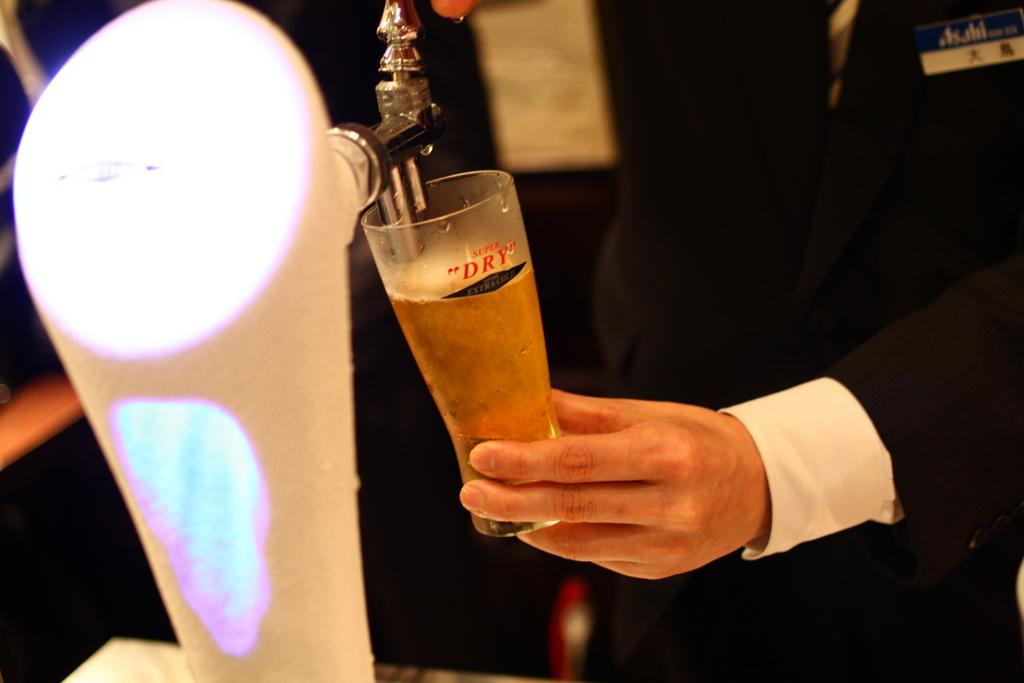<image>
Offer a succinct explanation of the picture presented. A man pull beer from a tap into a cup that says super dry. 